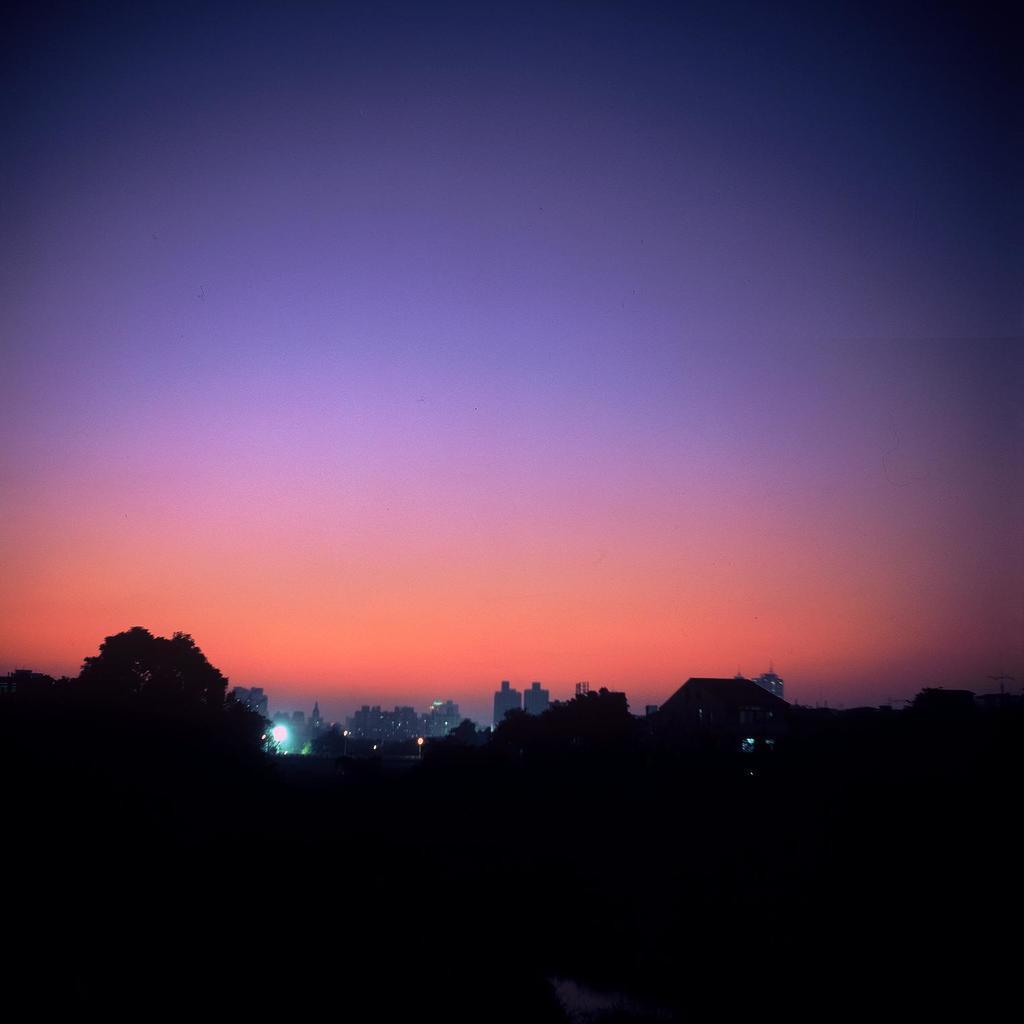How would you summarize this image in a sentence or two? In this image I can see number of buildings and few trees in front and I see that it is a bit dark. On the top of this picture I can see the sky. 